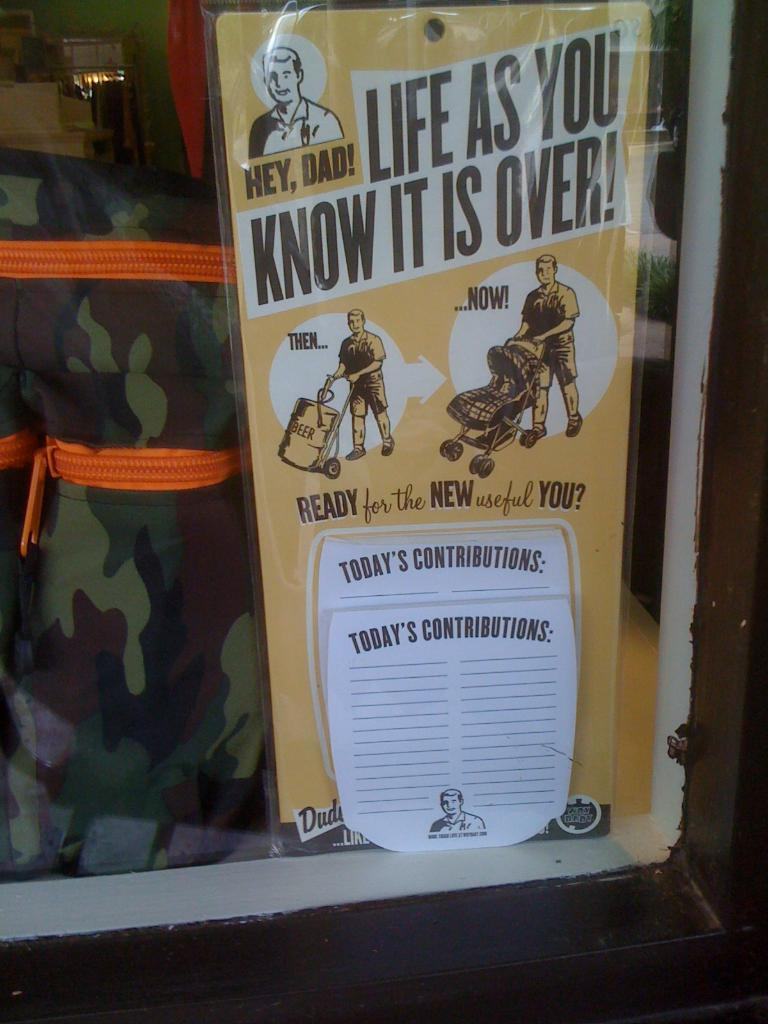<image>
Describe the image concisely. A sign in a window says Hey Dad!  Life as you know it is over! 